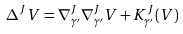<formula> <loc_0><loc_0><loc_500><loc_500>\Delta ^ { J } V = \nabla ^ { J } _ { \gamma ^ { \prime } } \nabla ^ { J } _ { \gamma ^ { \prime } } V + K ^ { J } _ { \gamma ^ { \prime } } ( V )</formula> 